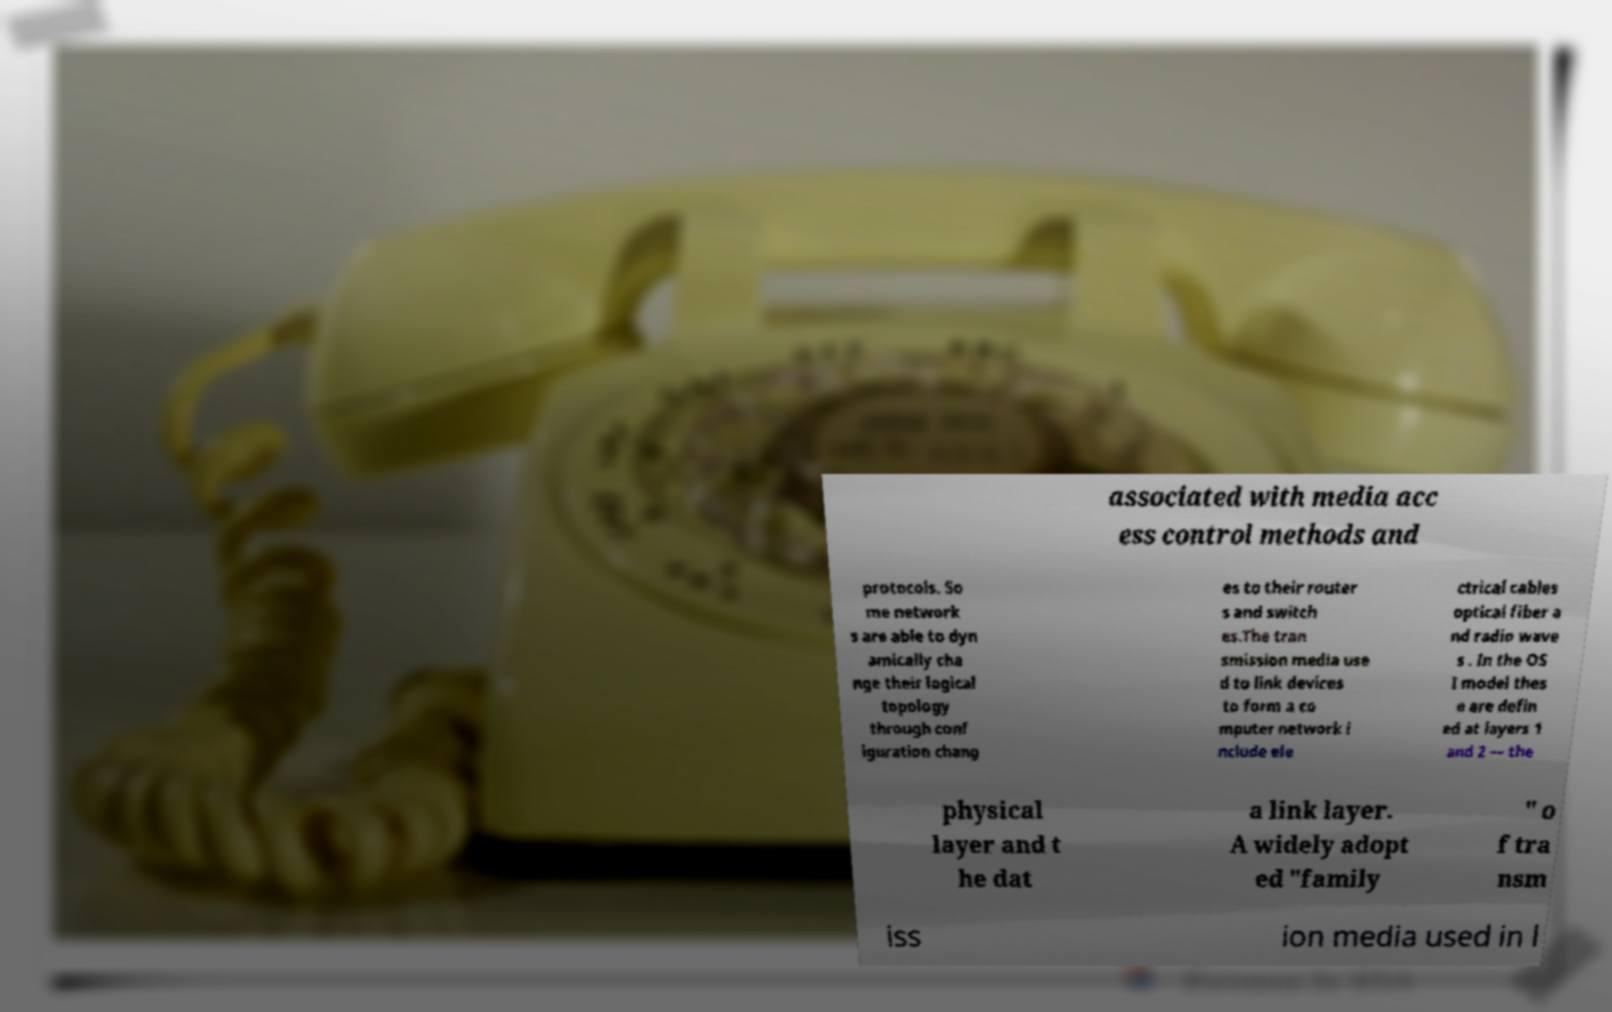Please read and relay the text visible in this image. What does it say? associated with media acc ess control methods and protocols. So me network s are able to dyn amically cha nge their logical topology through conf iguration chang es to their router s and switch es.The tran smission media use d to link devices to form a co mputer network i nclude ele ctrical cables optical fiber a nd radio wave s . In the OS I model thes e are defin ed at layers 1 and 2 — the physical layer and t he dat a link layer. A widely adopt ed "family " o f tra nsm iss ion media used in l 